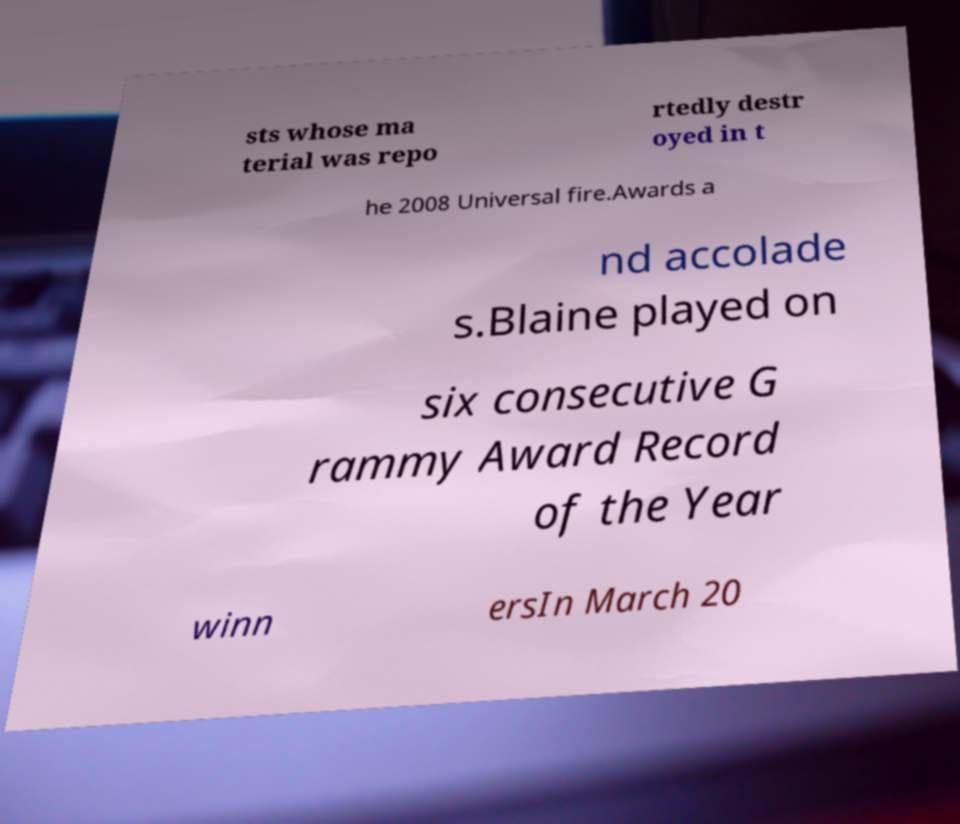Can you read and provide the text displayed in the image?This photo seems to have some interesting text. Can you extract and type it out for me? sts whose ma terial was repo rtedly destr oyed in t he 2008 Universal fire.Awards a nd accolade s.Blaine played on six consecutive G rammy Award Record of the Year winn ersIn March 20 